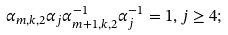<formula> <loc_0><loc_0><loc_500><loc_500>\alpha _ { m , k , 2 } \alpha _ { j } \alpha _ { m + 1 , k , 2 } ^ { - 1 } \alpha _ { j } ^ { - 1 } = 1 , j \geq 4 ;</formula> 